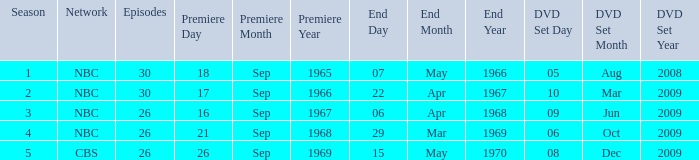What is the total season number for episodes later than episode 30? None. 